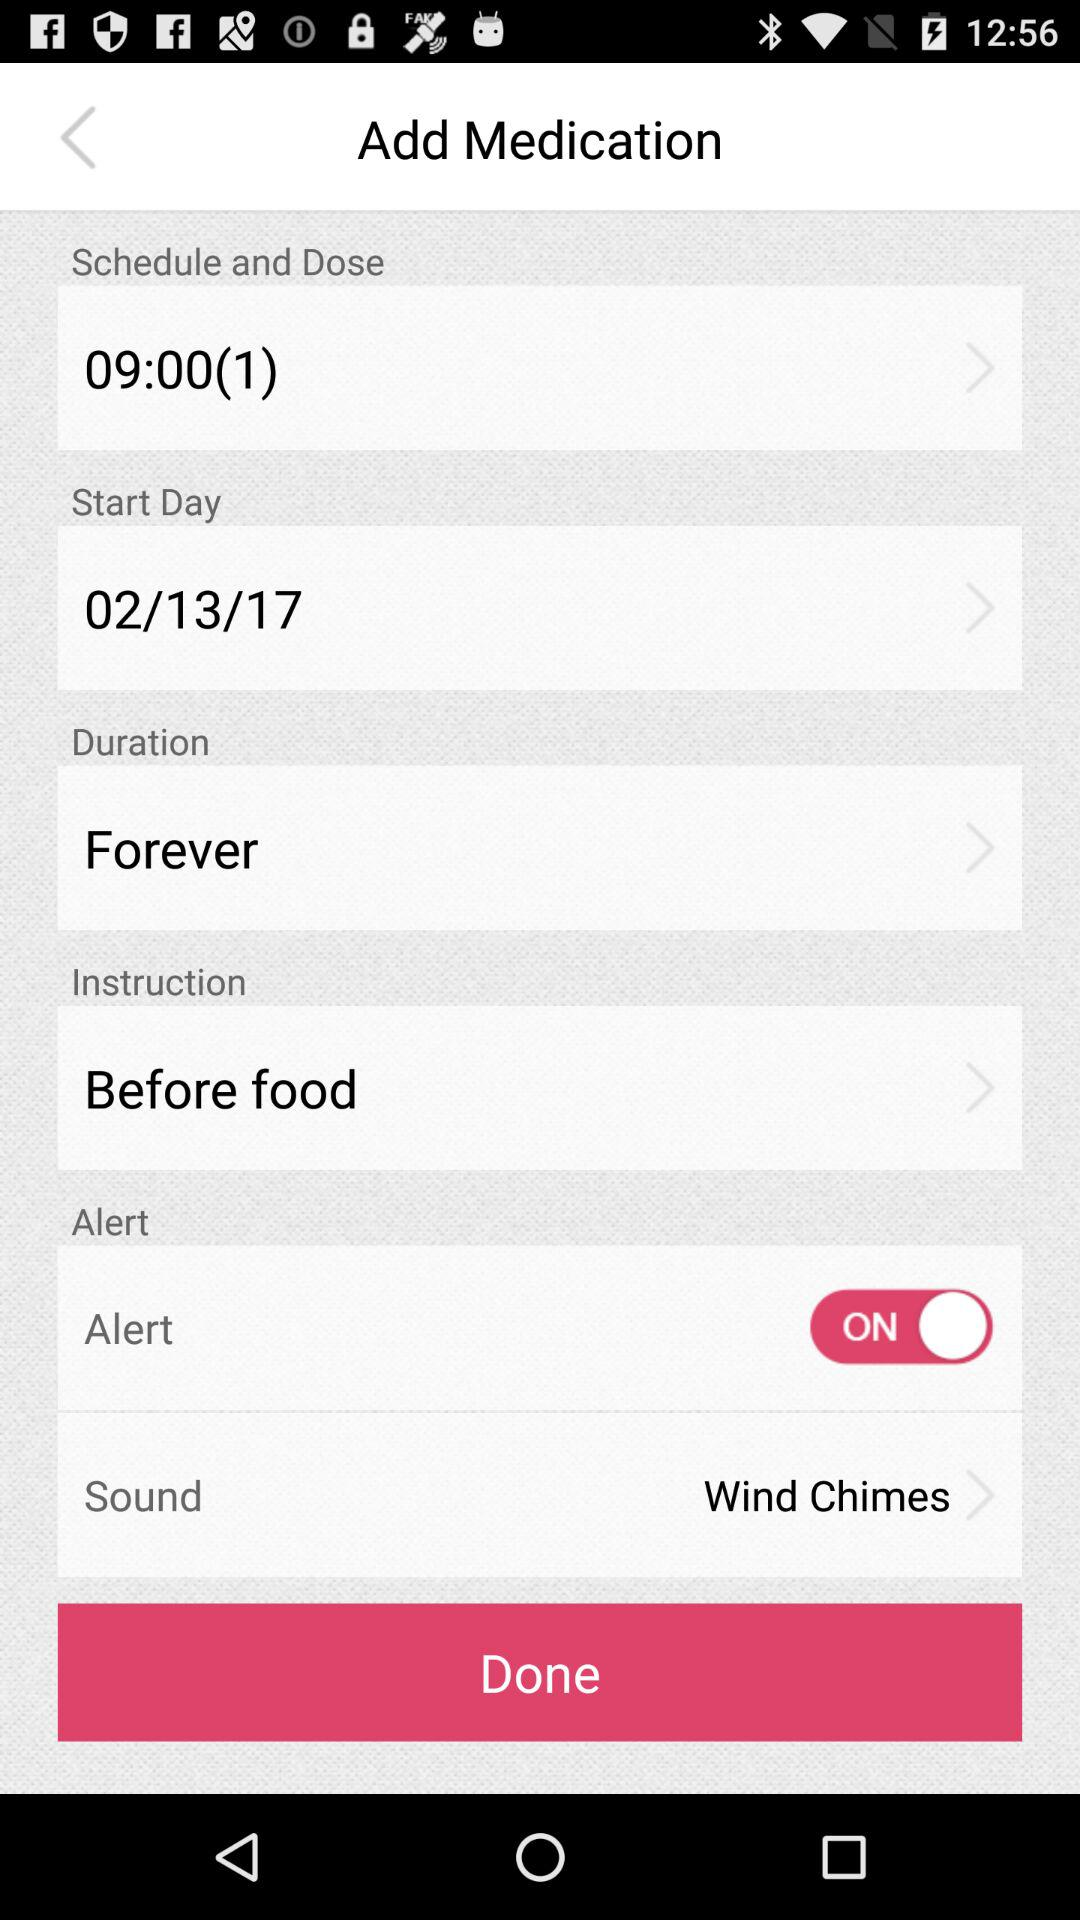What is the duration? The duration is "Forever". 